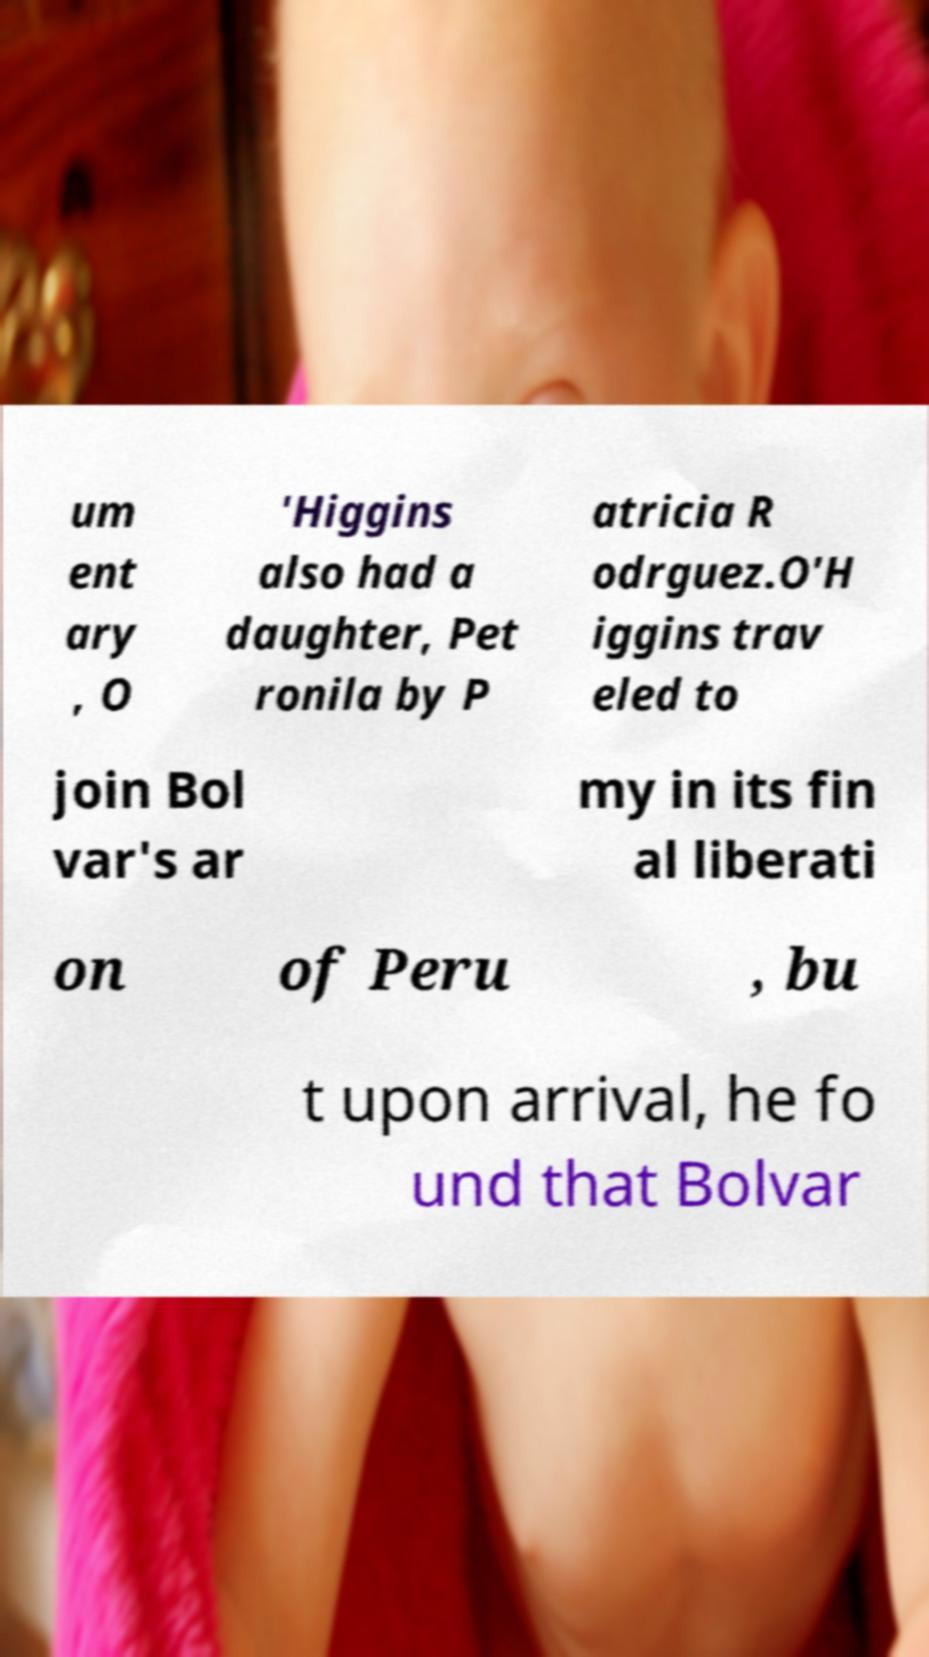For documentation purposes, I need the text within this image transcribed. Could you provide that? um ent ary , O 'Higgins also had a daughter, Pet ronila by P atricia R odrguez.O'H iggins trav eled to join Bol var's ar my in its fin al liberati on of Peru , bu t upon arrival, he fo und that Bolvar 